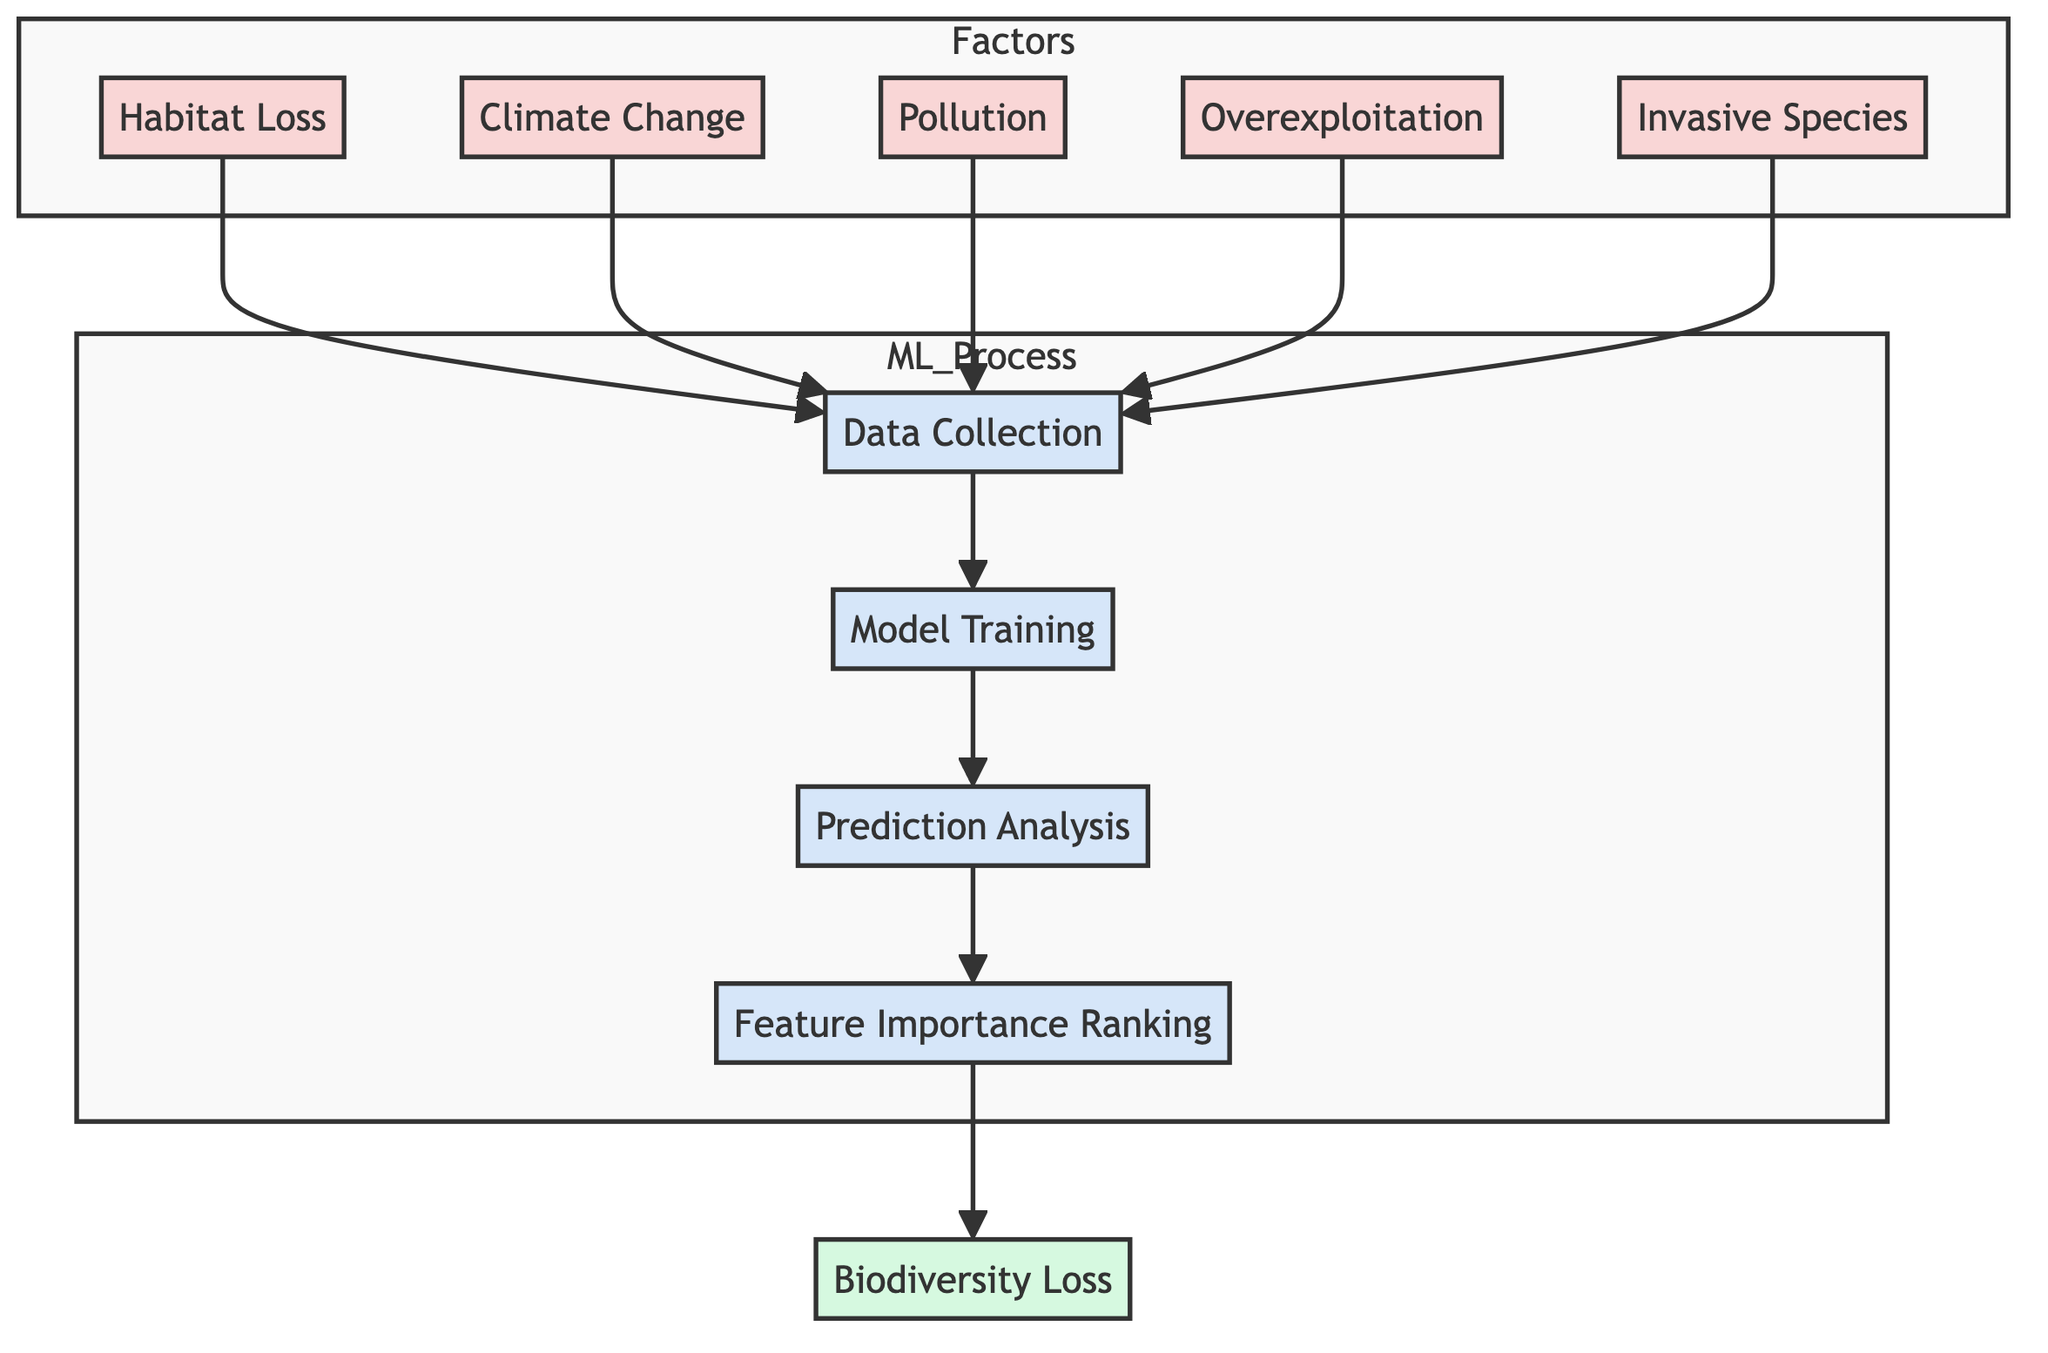What are the key factors influencing biodiversity loss indicated in the diagram? The diagram lists five key factors directly: Habitat Loss, Climate Change, Pollution, Overexploitation, and Invasive Species. These are presented in the 'Factors' subgraph.
Answer: Habitat Loss, Climate Change, Pollution, Overexploitation, Invasive Species How many nodes are present in the 'Factors' subgraph? The 'Factors' subgraph contains five nodes, representing the different key factors (Habitat Loss, Climate Change, Pollution, Overexploitation, and Invasive Species).
Answer: 5 What is the last process before reaching the output 'Biodiversity Loss'? The last process before reaching the output 'Biodiversity Loss' is Feature Importance Ranking, which ranks the importance of features determined during the analysis.
Answer: Feature Importance Ranking Which factors are connected to the data collection node? The data collection node is connected to all five key factors: Habitat Loss, Climate Change, Pollution, Overexploitation, and Invasive Species. They flow into the data collection process, indicating their role in the data input stage.
Answer: Habitat Loss, Climate Change, Pollution, Overexploitation, Invasive Species What type of node is 'Prediction Analysis'? 'Prediction Analysis' is categorized as a process node in the diagram. It represents a step in the machine learning process where the predictions are analyzed based on the trained model.
Answer: Process node What are the two immediate steps following Data Collection? The two immediate steps following Data Collection are Model Training and Prediction Analysis, which are the subsequent processes that leverage the collected data.
Answer: Model Training, Prediction Analysis How does Feature Importance Ranking contribute to the final output? Feature Importance Ranking evaluates the importance of the various features (factors) collected during the Data Collection, culminating in the final output of 'Biodiversity Loss' based on this evaluation.
Answer: Evaluates importance How many edges are there in the ML_Process subgraph? The ML_Process subgraph contains three edges that connect the stages: Data Collection to Model Training, Model Training to Prediction Analysis, and Prediction Analysis to Feature Importance Ranking.
Answer: 3 What influences the Biodiversity Loss output according to the diagram? The output 'Biodiversity Loss' is influenced by the result of the Feature Importance Ranking process, which summarizes the impact of the five key factors analyzed in the machine learning pipeline.
Answer: Feature Importance Ranking 